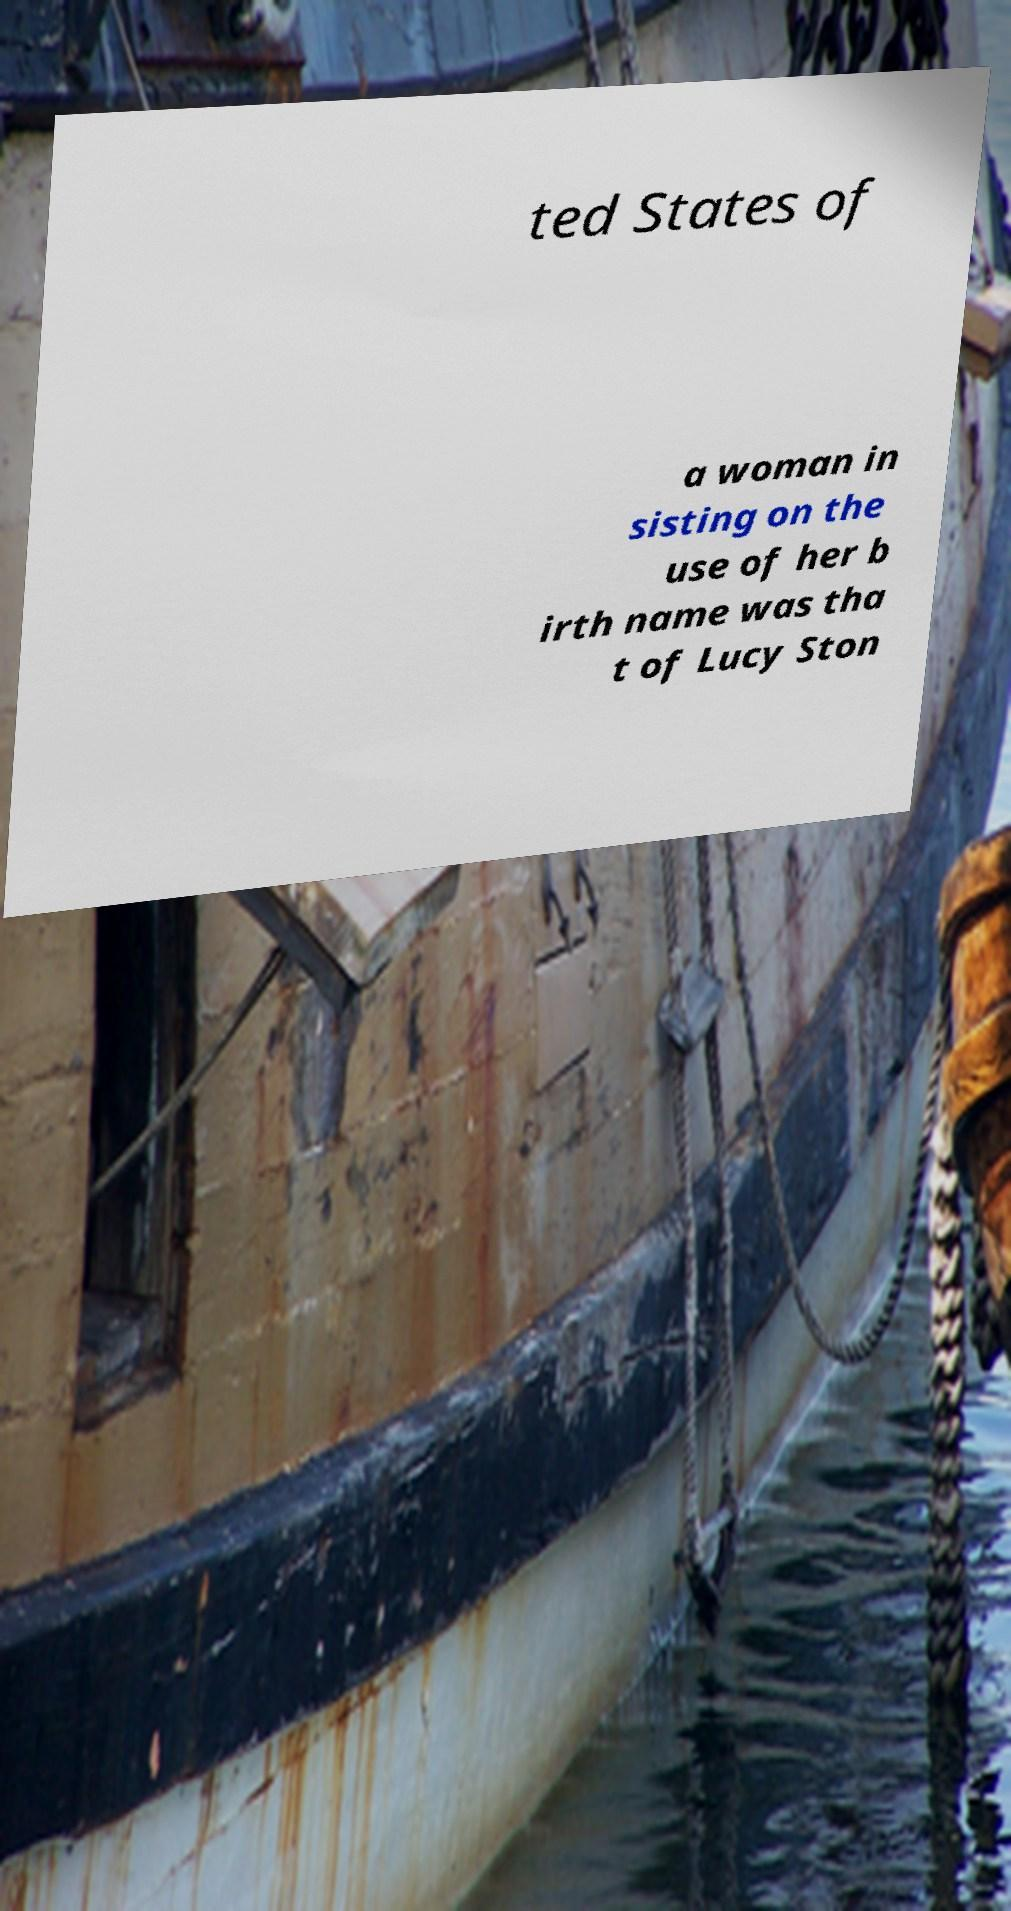Could you assist in decoding the text presented in this image and type it out clearly? ted States of a woman in sisting on the use of her b irth name was tha t of Lucy Ston 